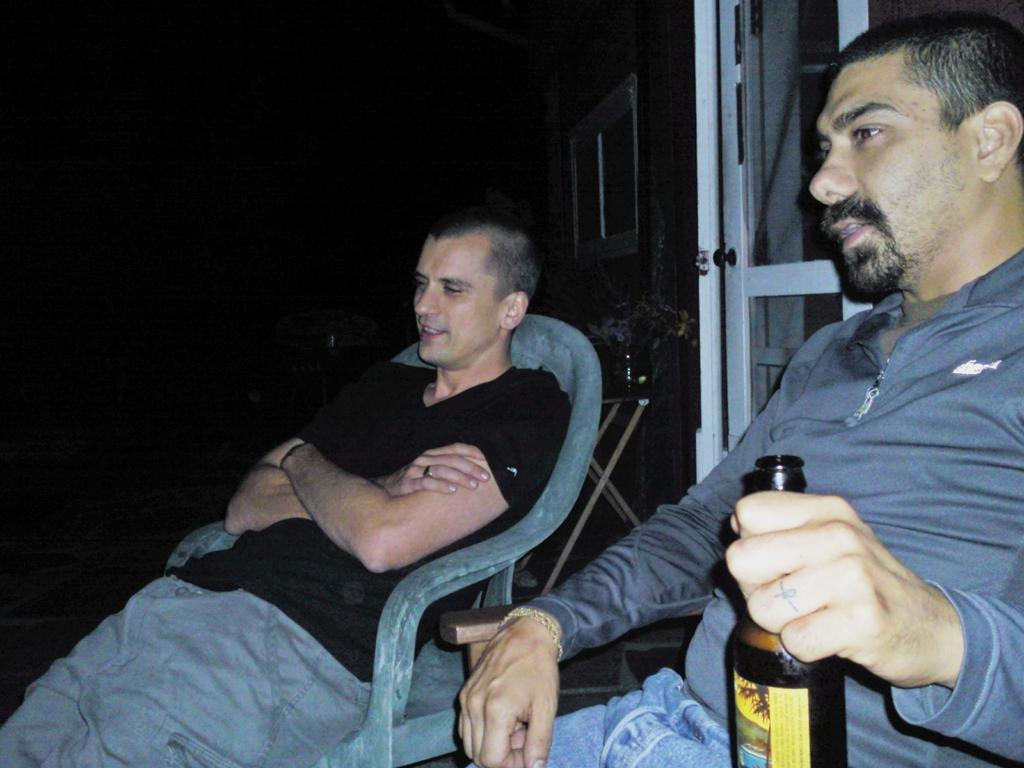How many people are in the image? There are two persons in the image. What are the persons doing in the image? The persons are sitting on chairs. Can you describe the action of one of the persons? One person is catching a bottle with their hand. What subject is the person teaching in the image? There is no indication in the image that the person is teaching, so it cannot be determined from the picture. 